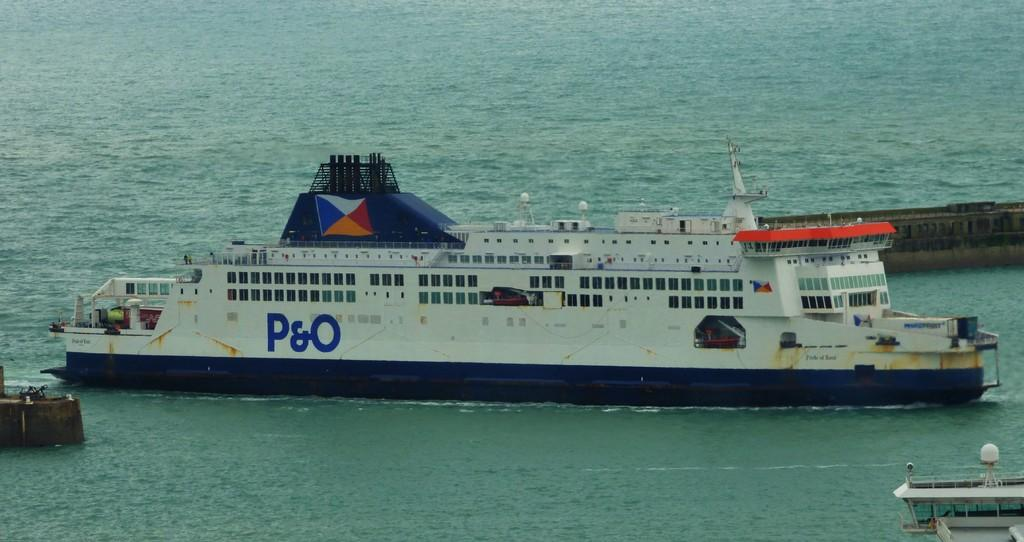What is the main subject of the image? There is a ship in the water. What can be seen in the background of the image? There is a bridge behind the ship. What is visible at the bottom of the image? Water is visible at the bottom of the image. What type of structure is the ship? The ship has rooms. What type of underwear is the ship wearing in the image? Ships do not wear underwear, as they are inanimate objects. 